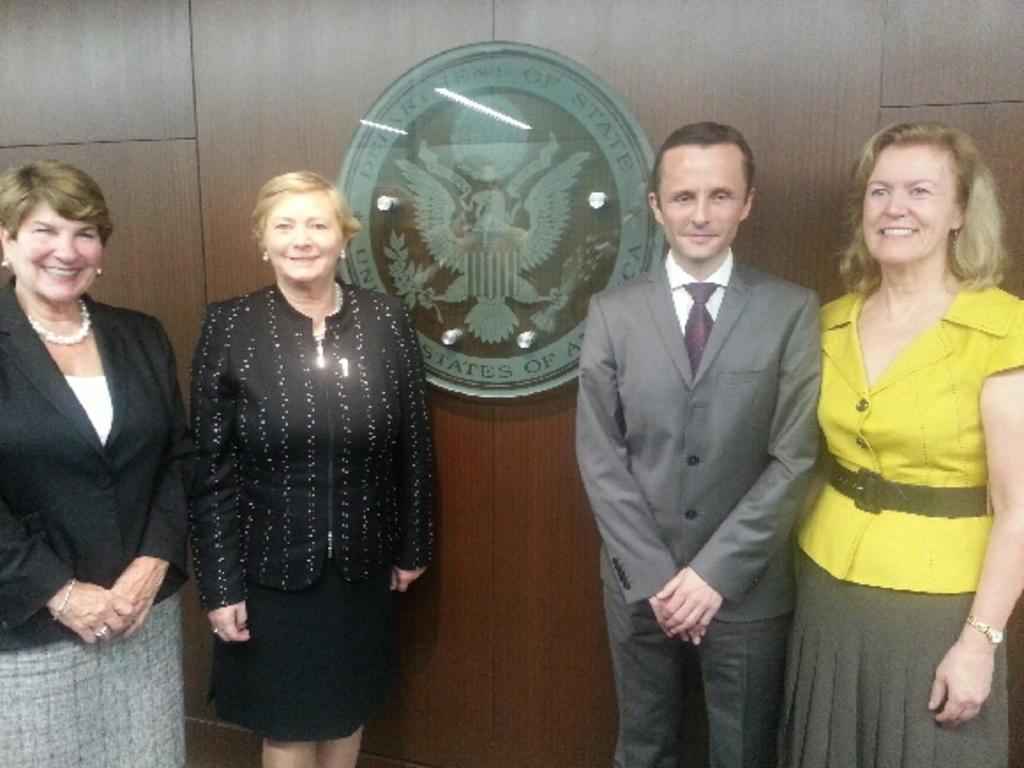How many people are present in the image? There are four persons standing in the image. What can be seen in the background of the image? There is a wall with an emblem in the background of the image. What is written on the emblem? Unfortunately, the specific text on the emblem cannot be determined from the image. What type of body pain is the person on the left experiencing in the image? There is no indication of any body pain or discomfort in the image; the four persons are standing and appear to be in good health. 